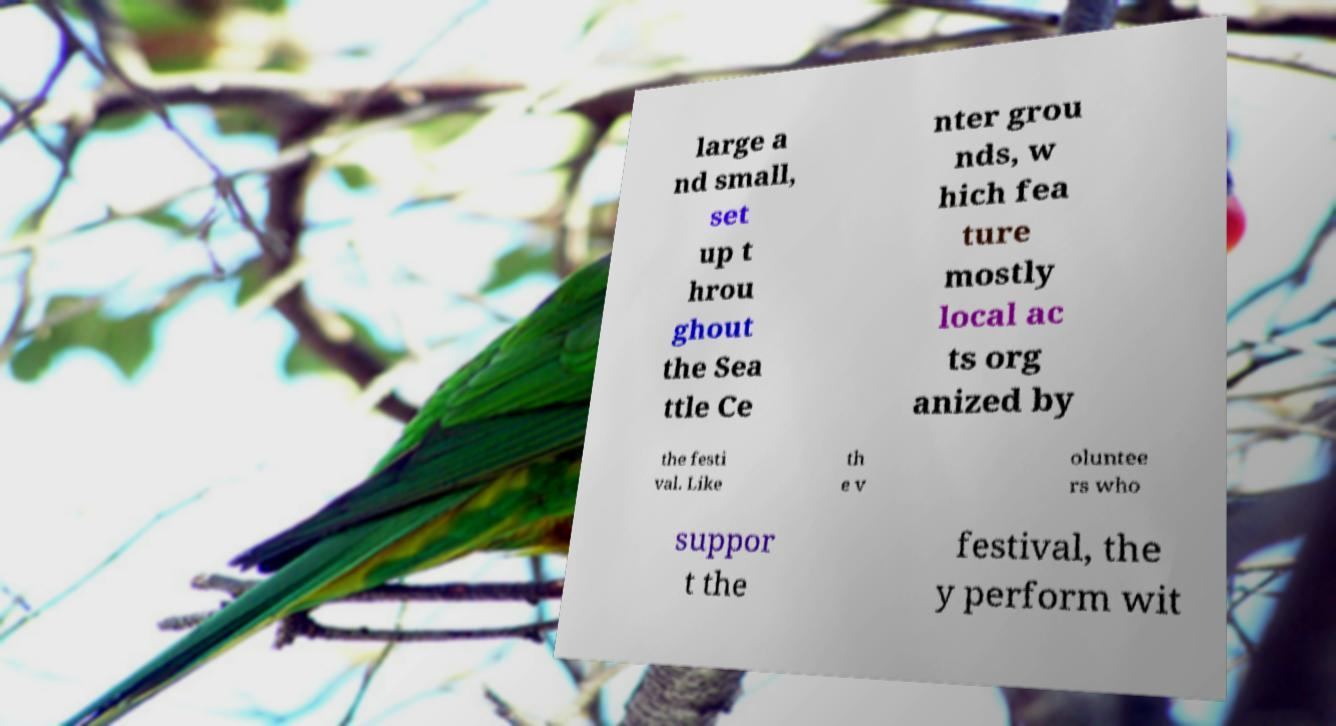Could you extract and type out the text from this image? large a nd small, set up t hrou ghout the Sea ttle Ce nter grou nds, w hich fea ture mostly local ac ts org anized by the festi val. Like th e v oluntee rs who suppor t the festival, the y perform wit 